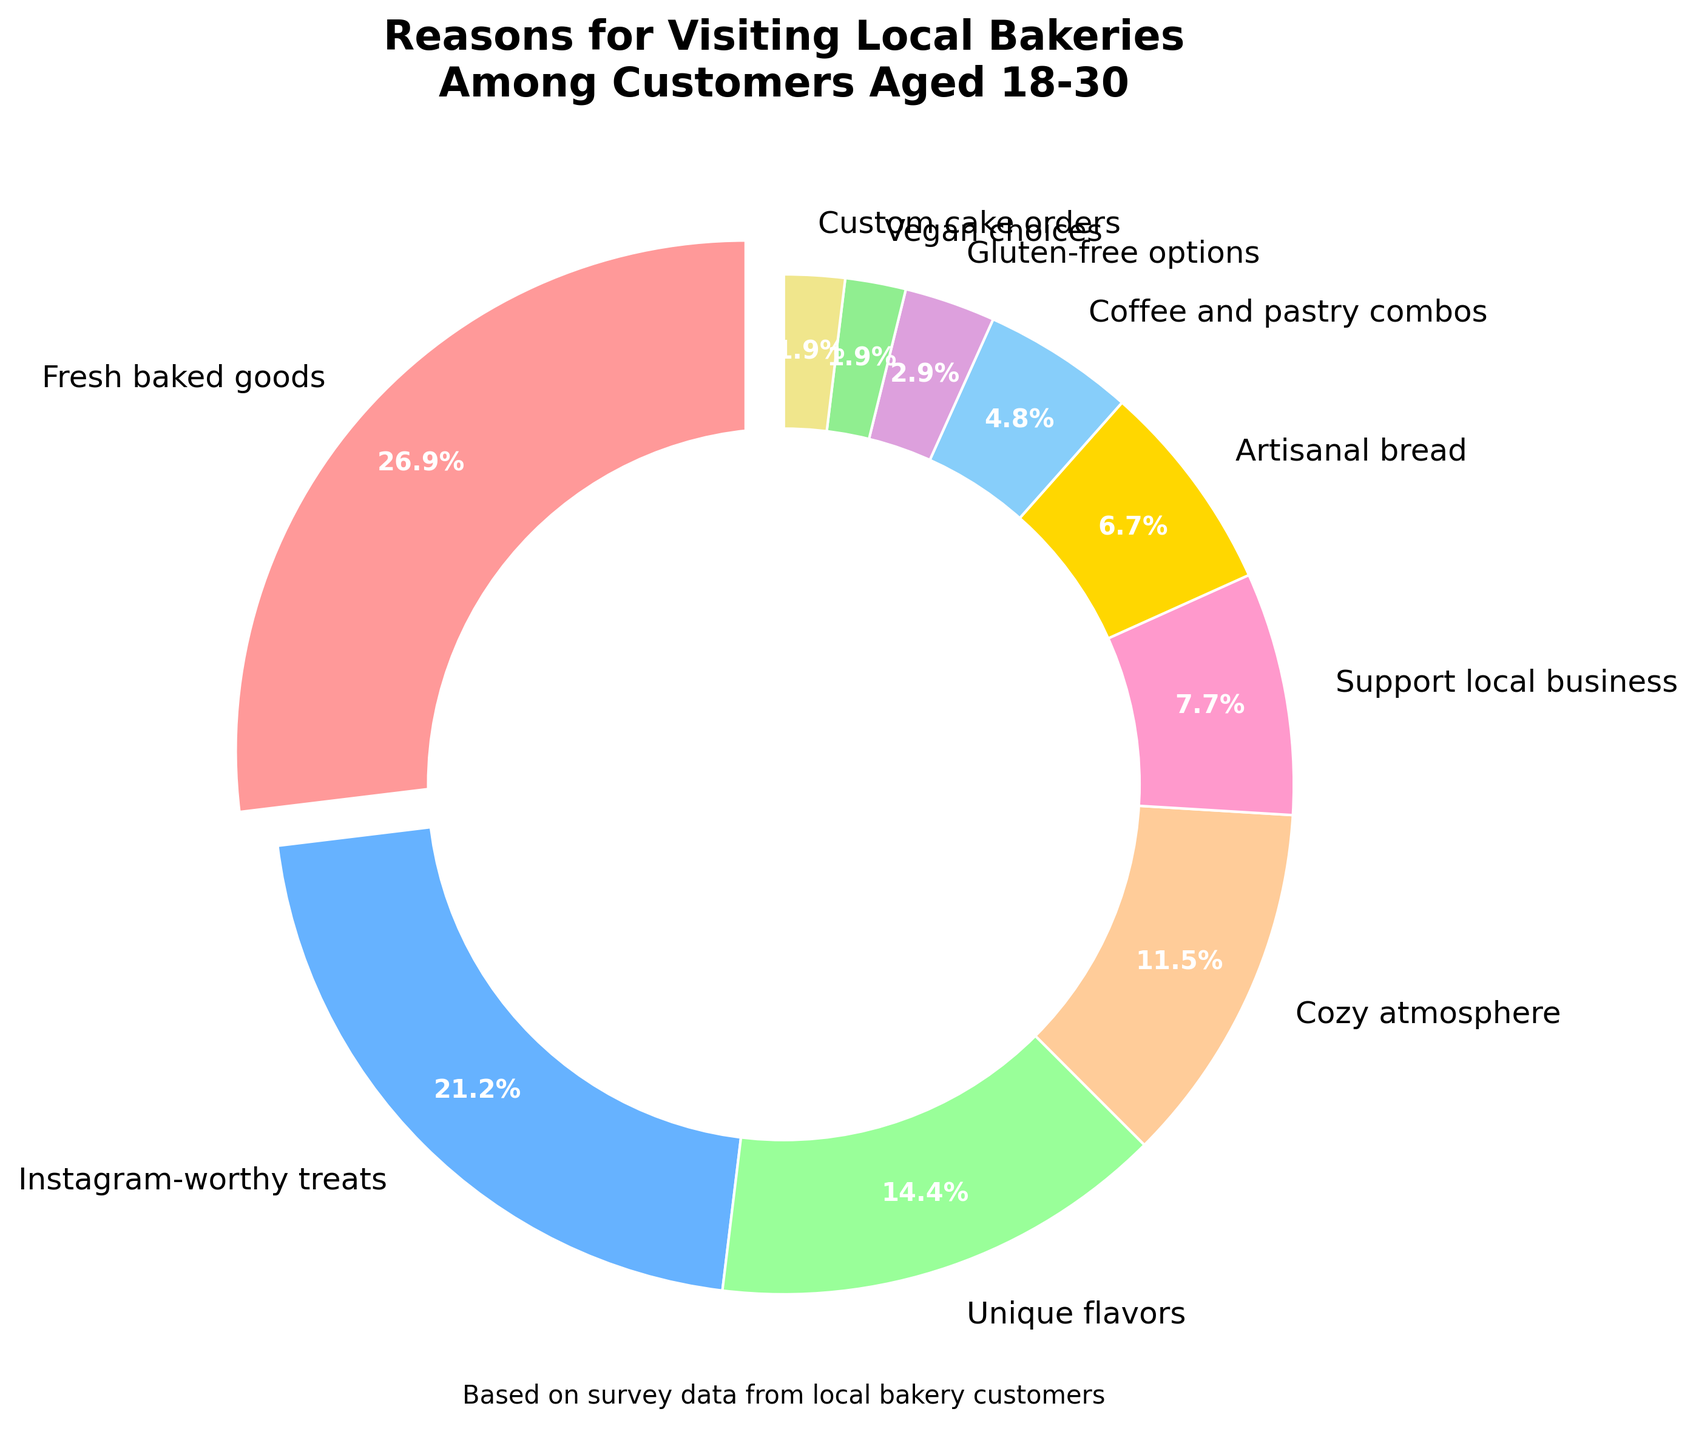Which reason is the most popular among customers aged 18-30 for visiting local bakeries? The largest slice in the pie chart, which is exploded, represents the most popular reason. In this case, it’s "Fresh baked goods" with 28%.
Answer: Fresh baked goods Which reason is the least popular among customers aged 18-30 for visiting local bakeries? The smallest slice in the pie chart represents the least popular reason, which is "Vegan choices" with 2%.
Answer: Vegan choices Which reasons for visiting local bakeries have a combined percentage of less than 10%? Adding the percentages for “Gluten-free options” (3%), “Vegan choices” (2%), and “Custom cake orders” (2%) gives a combined percentage of 7%, which is less than 10%.
Answer: Gluten-free options, Vegan choices, Custom cake orders How much more popular is the "Fresh baked goods" reason compared to "Cozy atmosphere"? Calculate the difference between the percentages of "Fresh baked goods" (28%) and "Cozy atmosphere" (12%), which is 28 - 12.
Answer: 16% Which reasons have a percentage closer to "Unique flavors" than to "Instagram-worthy treats"? "Unique flavors" is at 15%. The reasons need to have percentages nearer to 15% than to 22%. “Cozy atmosphere” at 12% is closer to 15% than to 22%.
Answer: Cozy atmosphere Which color represents the most popular reason, and which one represents the least popular reason in the pie chart? The slice representing the most popular reason, "Fresh baked goods" (28%), is exploded and colored pink. The least popular reason, "Vegan choices" (2%), is colored light green.
Answer: Pink, Light green If you combined the percentages for "Instagram-worthy treats" and "Unique flavors," would they surpass "Fresh baked goods"? Adding the percentages for "Instagram-worthy treats" (22%) and "Unique flavors" (15%) gives 22 + 15, which equals 37%. "Fresh baked goods" is at 28%. Yes, 37% is greater than 28%.
Answer: Yes What is the total percentage for reasons related to health-conscious choices like "Gluten-free options" and "Vegan choices"? Adding "Gluten-free options" (3%) and "Vegan choices" (2%) gives 3 + 2, which is 5%.
Answer: 5% How many reasons have a percentage above the average percentage of all reasons for visiting local bakeries? Summing all percentages gives 100%. There are 10 reasons, so the average is 100/10, which is 10%. The reasons above 10% are "Fresh baked goods" (28%), "Instagram-worthy treats" (22%), "Unique flavors" (15%), and "Cozy atmosphere" (12%). There are 4 reasons.
Answer: 4 If the percentage for "Support local business" increased by 4%, what would its new percentage be, and how would it rank among the reasons? Adding 4% to "Support local business" (8%) gives 8 + 4, which is 12%. This new percentage would make it equal to "Cozy atmosphere," ranking it behind "Fresh baked goods," "Instagram-worthy treats," and "Unique flavors," thus being tied for fourth place.
Answer: 12%, tied for fourth 